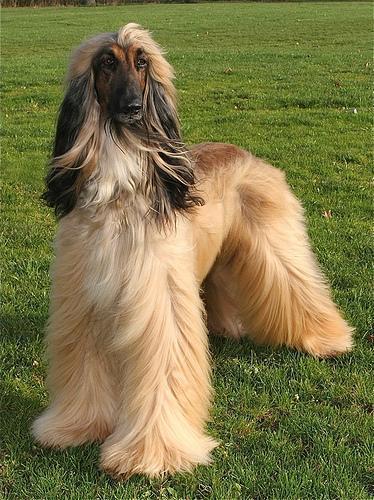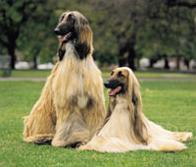The first image is the image on the left, the second image is the image on the right. For the images shown, is this caption "There are exactly three dogs in total." true? Answer yes or no. Yes. The first image is the image on the left, the second image is the image on the right. Examine the images to the left and right. Is the description "One photo contains exactly two dogs while the other photo contains only one, and all dogs are photographed outside in grass." accurate? Answer yes or no. Yes. 